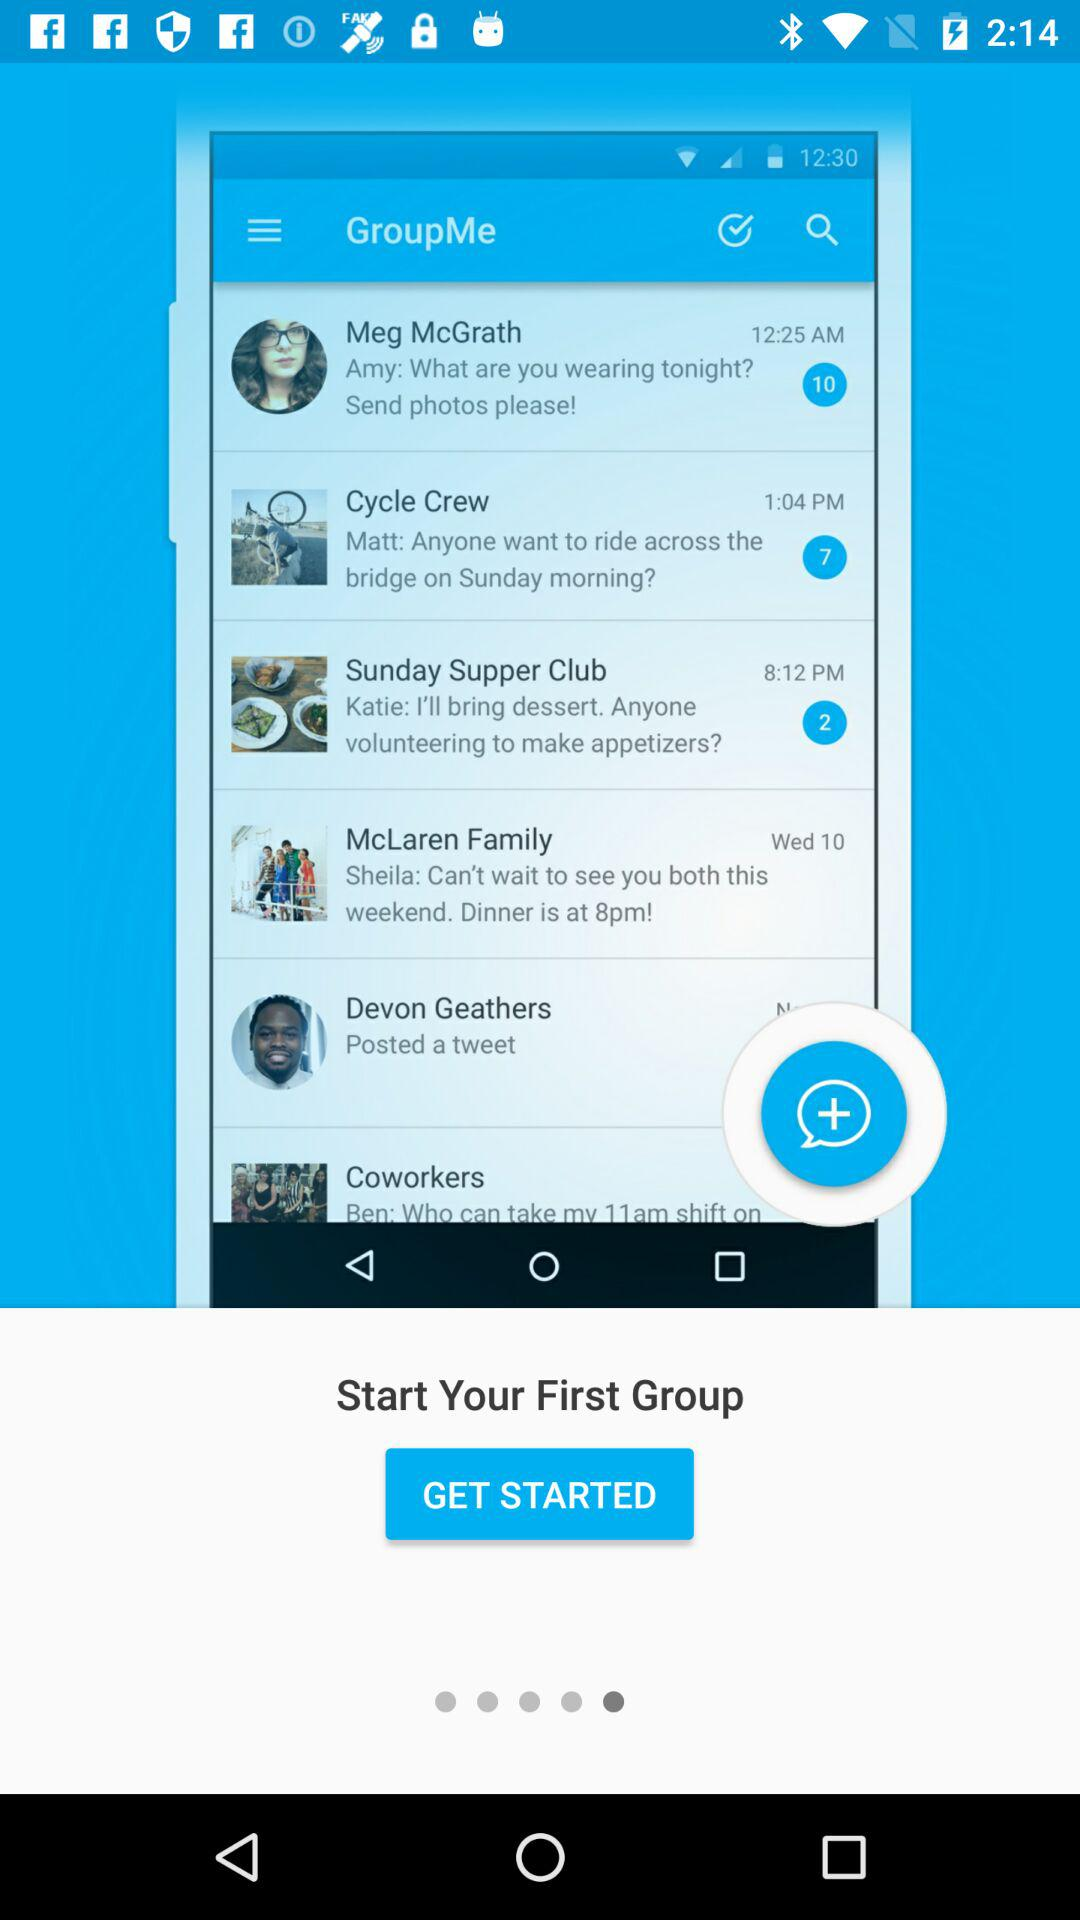How many minutes ago was the Sunday super club group active?
When the provided information is insufficient, respond with <no answer>. <no answer> 